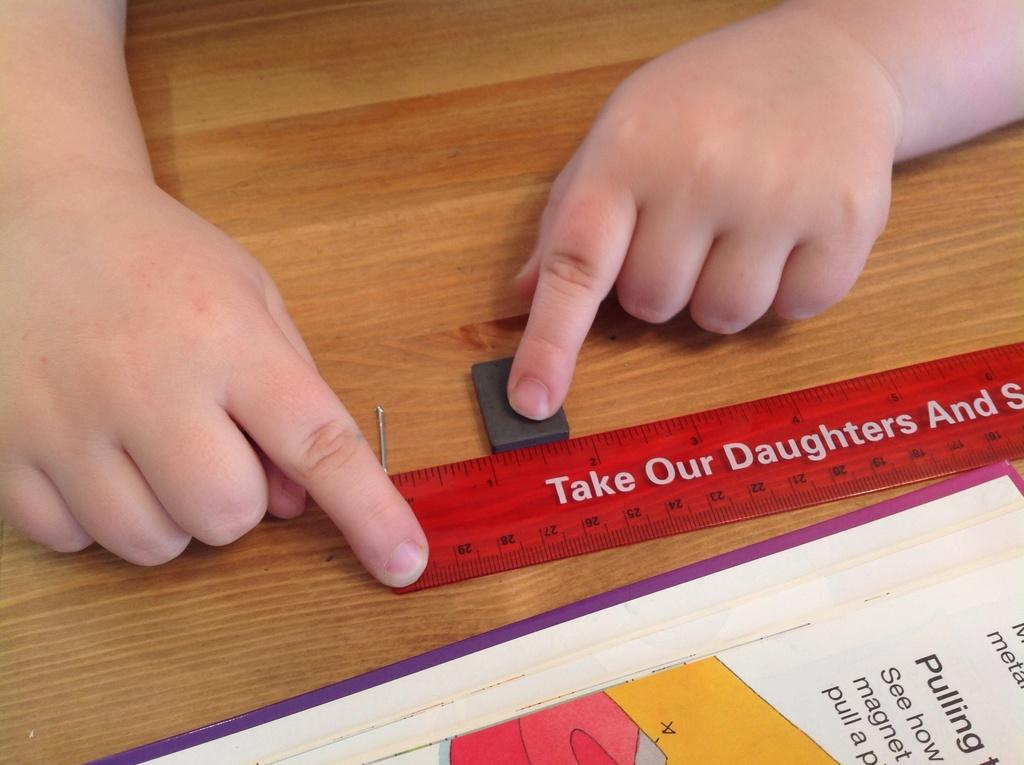<image>
Offer a succinct explanation of the picture presented. A ruler that has the word daughters on it is being used on a wood surface. 